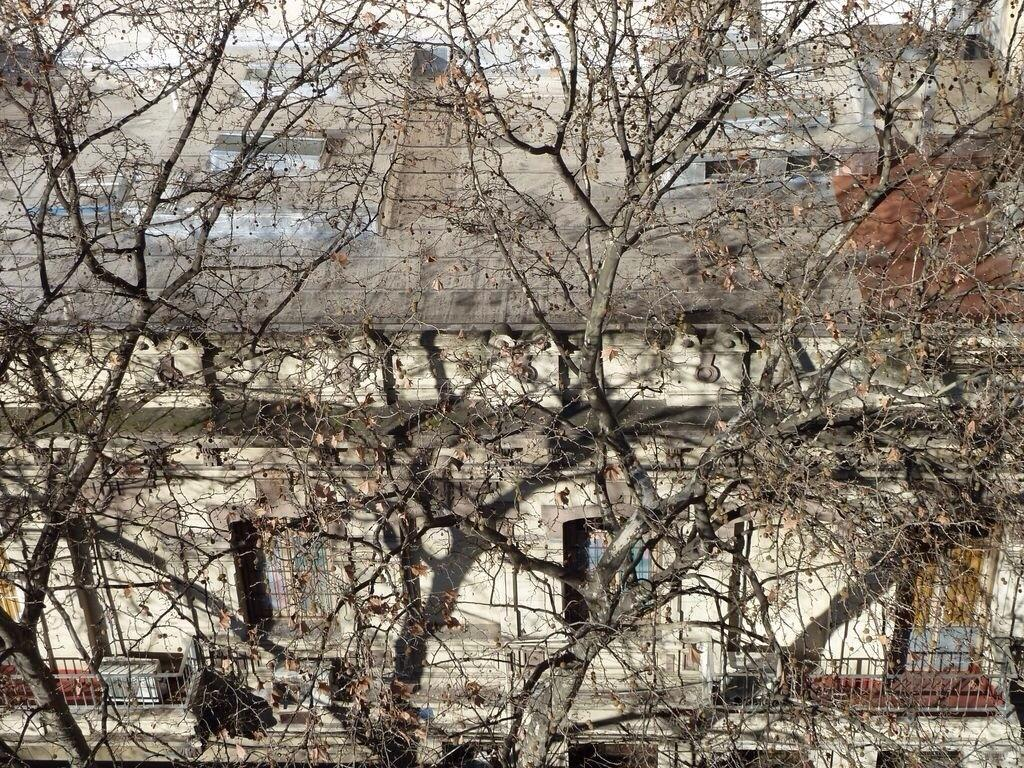What type of structure is present in the image? There is a building in the image. What feature can be seen on the building? The building has windows. What safety feature is visible in the image? There is a railing in the image. What type of vegetation is present in the image? There are dry trees in the image. What can be seen in the distance in the image? There are objects visible in the background of the image. How many snails can be seen crawling on the building in the image? There are no snails visible in the image. What color is the kitty sitting on the railing in the image? There is no kitty present in the image. 